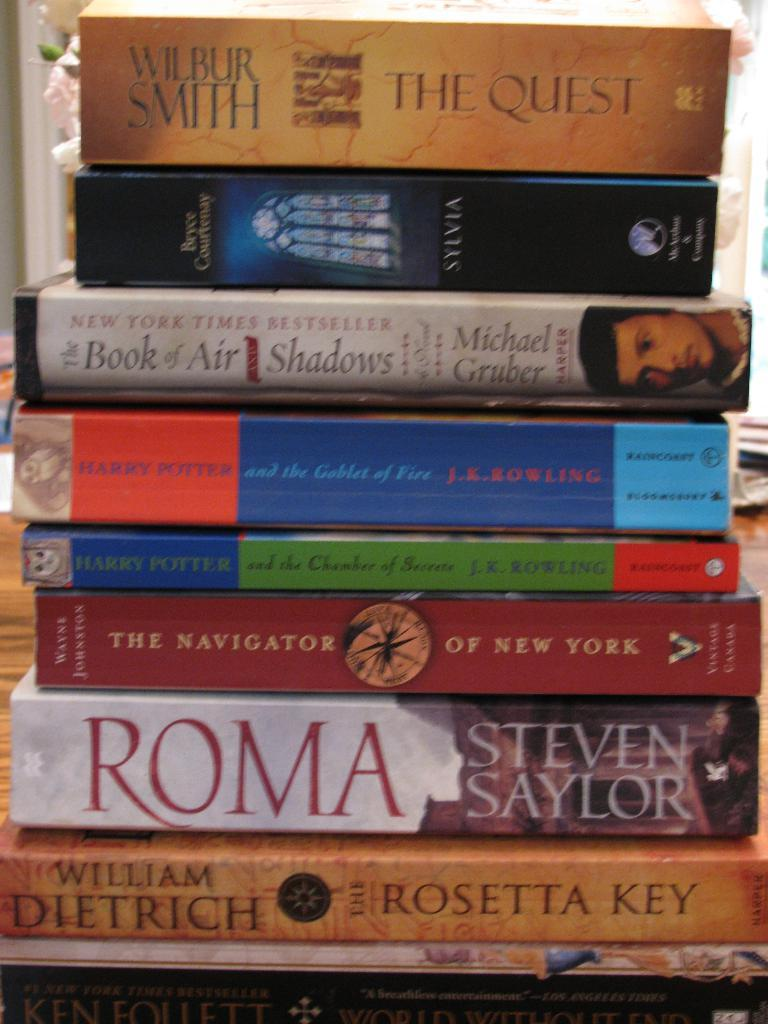Provide a one-sentence caption for the provided image. a stack of books with the  Quest by Wilbur Smith on top. 